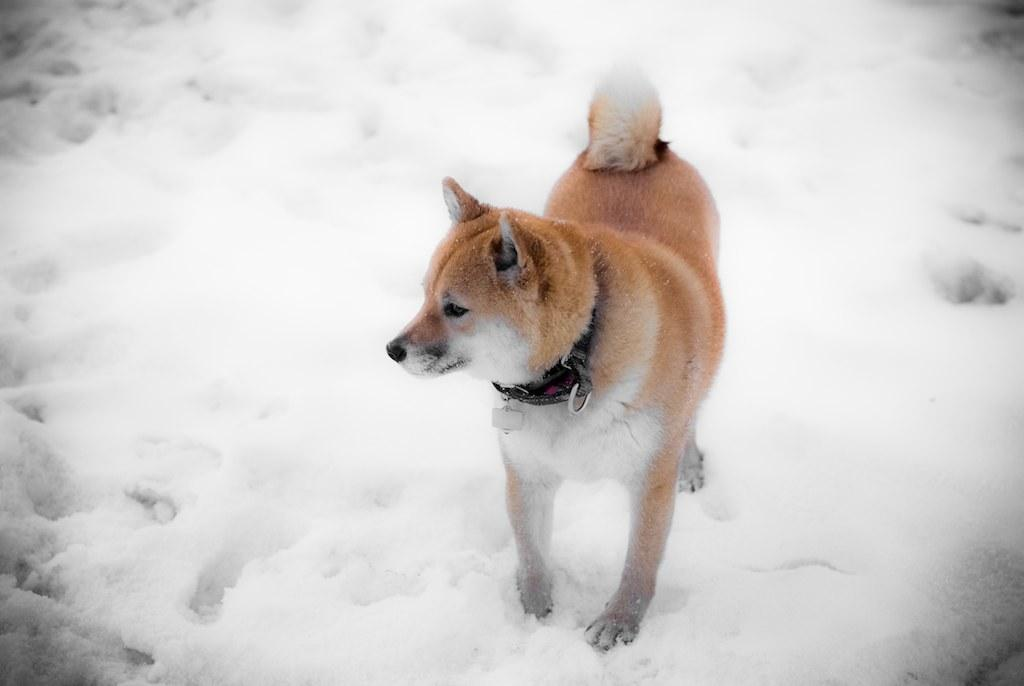What type of animal is in the image? There is a dog in the image. What is the dog standing on? The dog is standing on a snow land. What type of oven can be seen in the image? There is no oven present in the image; it features a dog standing on a snow land. What type of animal is flying in the image? There is no animal flying in the image; it features a dog standing on a snow land. 